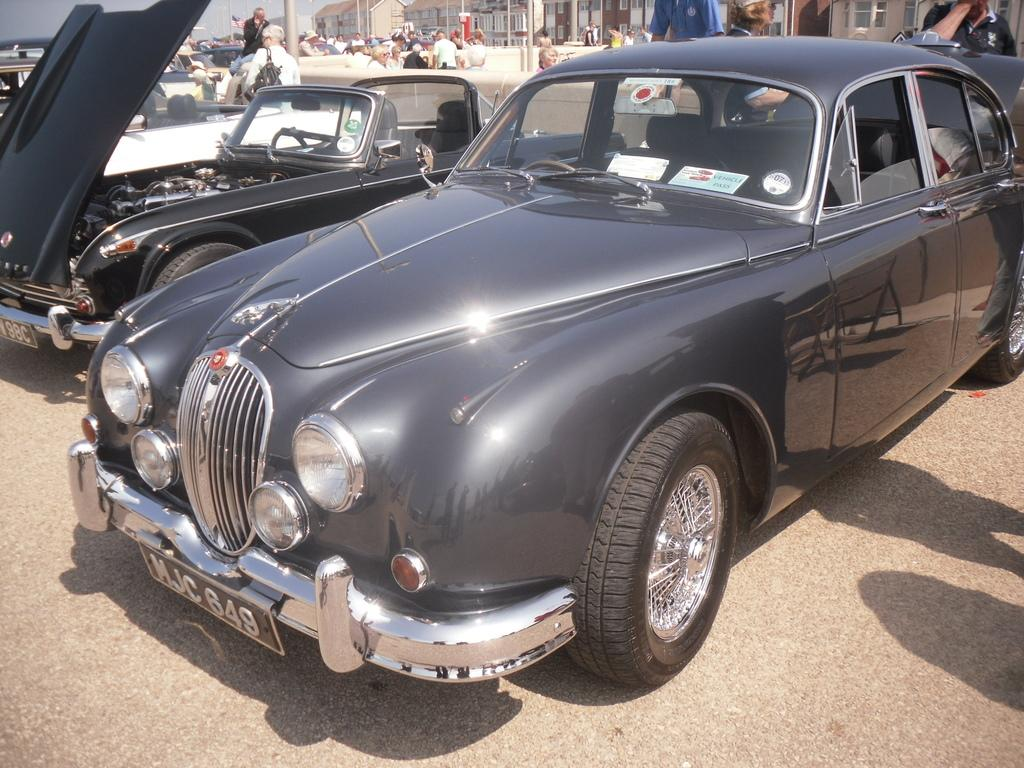What is happening on the road in the image? There are vehicles on the road in the image. What can be seen in the background of the image? There are people, buildings, and poles in the background of the image. Can you see a snail crawling on the buildings in the image? There is no snail visible in the image; it only features vehicles on the road, people, buildings, and poles in the background. 